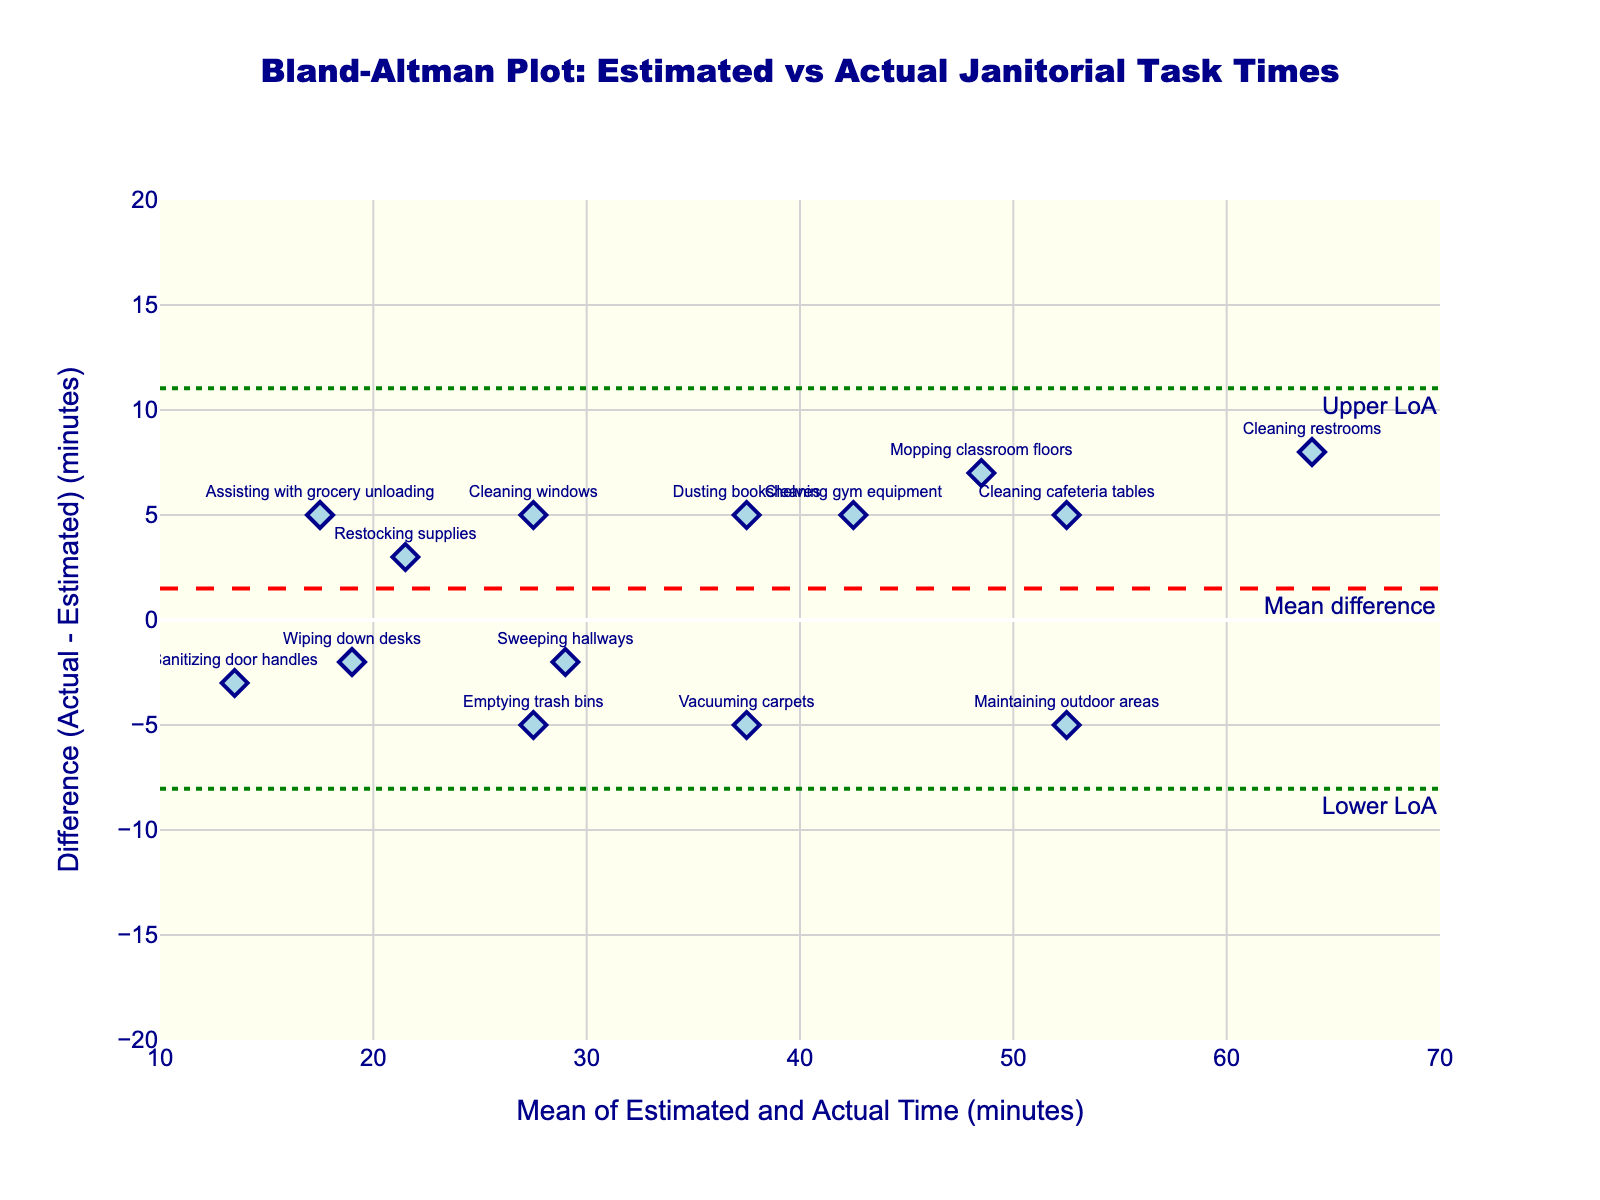How many janitorial tasks are plotted on the Bland-Altman plot? Count the number of data points (diamonds) shown on the plot. Each point corresponds to a janitorial task.
Answer: 14 What is the title of the plot? Look at the top of the figure where the title is displayed.
Answer: Bland-Altman Plot: Estimated vs Actual Janitorial Task Times What is the mean difference between the estimated and actual task times? Look for the line labeled "Mean difference" on the y-axis and note its value.
Answer: 1 Which task showed the highest positive difference between actual and estimated times? Locate the data point farthest above the y=0 line, then read the task's label next to the corresponding data point.
Answer: Cleaning restrooms How is the X-axis labeled? Read the label on the X-axis of the figure.
Answer: Mean of Estimated and Actual Time (minutes) What are the limits of agreement for the plot? Look at the y-axis values where the "Lower LoA" and "Upper LoA" lines are drawn and note these values.
Answer: Approximately -8 and 10 Which task had an equal estimated and actual time? Identify the data point that lies on the y=0 line, signifying no difference, then check the task's label.
Answer: Emptying trash bins What is the average mean of the estimated and actual times for "Cleaning windows"? Find the data point for "Cleaning windows" and identify its x-value. The x-value represents the mean of estimated and actual times.
Answer: 27.5 Which task had the largest negative difference between actual and estimated time? Identify the data point farthest below the y=0 line and read the task's label.
Answer: Assisting with grocery unloading What is the actual time recorded for "Sanitizing door handles", and how does it compare to the estimated time? Find the data point for "Sanitizing door handles". The y-coordinate of this point shows the difference, add it to the estimated time to get the actual time. Compare these values.
Answer: Actual: 12 minutes, Estimated: 15 minutes; the actual time is 3 minutes less than estimated 